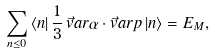<formula> <loc_0><loc_0><loc_500><loc_500>\sum _ { n \leq 0 } \, \langle n | \, \frac { 1 } { 3 } \, \vec { v } a r { \alpha } \cdot \vec { v } a r { p } \, | n \rangle = E _ { M } ,</formula> 